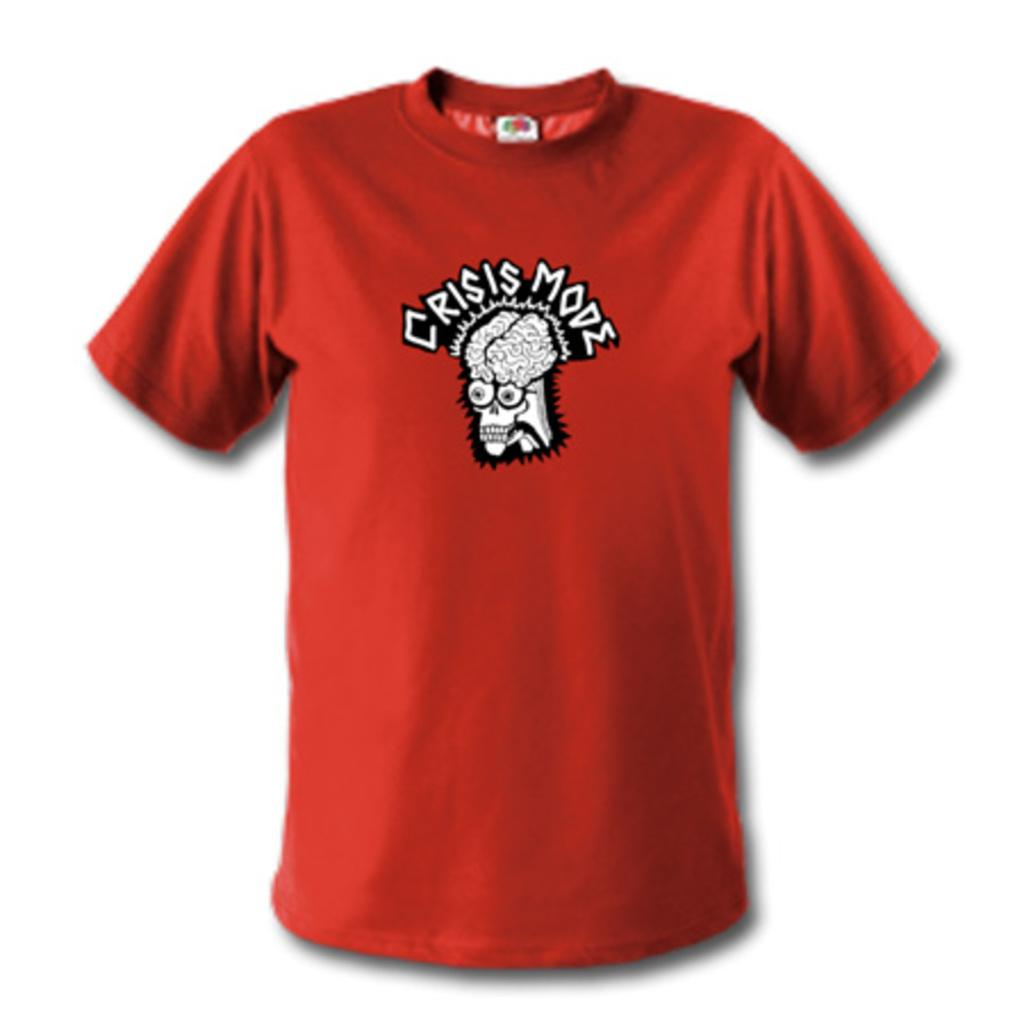What color is the t-shirt in the image? The t-shirt in the image is red. Can you describe the background of the image? The background of the image is blurred. How many bikes are parked on the page in the image? There are no bikes or pages present in the image; it only features a red t-shirt and a blurred background. 